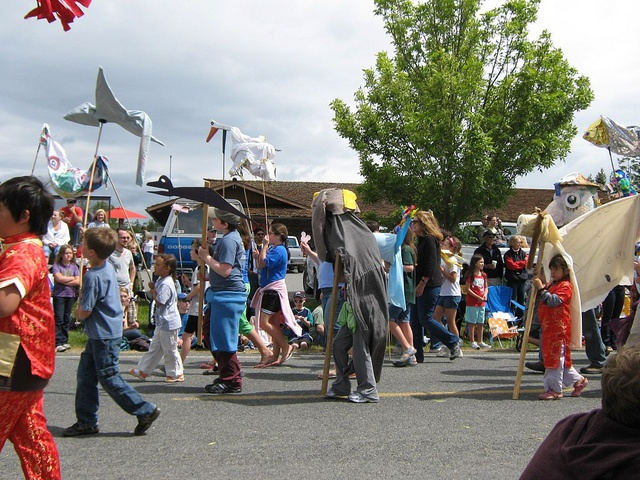Describe the objects in this image and their specific colors. I can see people in lightgray, black, gray, and darkgray tones, people in lightgray, black, maroon, brown, and salmon tones, people in lightgray, black, gray, and darkgray tones, people in lightgray, black, gray, navy, and blue tones, and people in lightgray, black, gray, and navy tones in this image. 